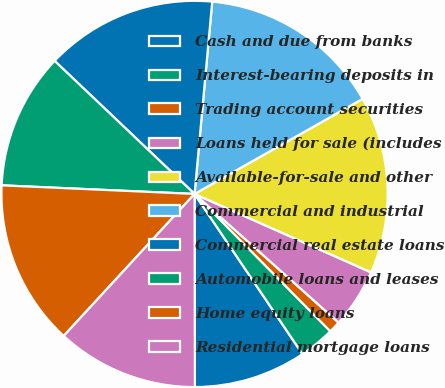Convert chart to OTSL. <chart><loc_0><loc_0><loc_500><loc_500><pie_chart><fcel>Cash and due from banks<fcel>Interest-bearing deposits in<fcel>Trading account securities<fcel>Loans held for sale (includes<fcel>Available-for-sale and other<fcel>Commercial and industrial<fcel>Commercial real estate loans<fcel>Automobile loans and leases<fcel>Home equity loans<fcel>Residential mortgage loans<nl><fcel>9.41%<fcel>2.97%<fcel>0.99%<fcel>4.95%<fcel>14.85%<fcel>15.35%<fcel>14.36%<fcel>11.39%<fcel>13.86%<fcel>11.88%<nl></chart> 